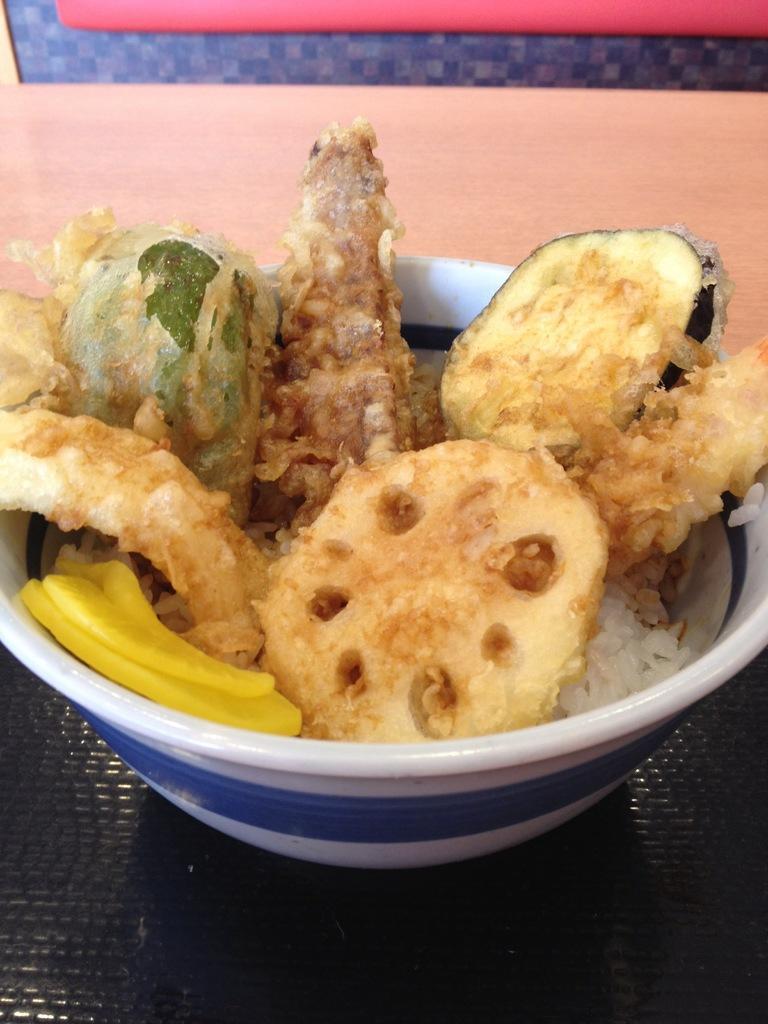How would you summarize this image in a sentence or two? In this picture I can see a food item in a bowl, on the table, and in the background there is an object. 